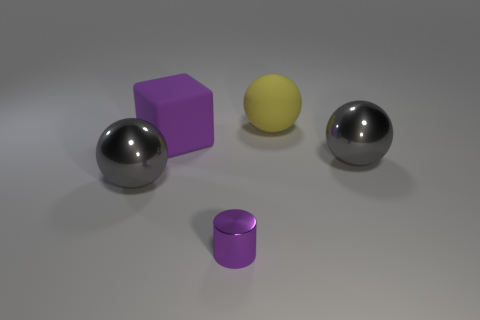Subtract all big metallic spheres. How many spheres are left? 1 Subtract all purple cylinders. How many gray spheres are left? 2 Subtract all gray balls. How many balls are left? 1 Add 3 big yellow spheres. How many objects exist? 8 Subtract 1 balls. How many balls are left? 2 Add 1 big gray metal things. How many big gray metal things are left? 3 Add 4 tiny brown cylinders. How many tiny brown cylinders exist? 4 Subtract 0 red spheres. How many objects are left? 5 Subtract all cubes. How many objects are left? 4 Subtract all red spheres. Subtract all purple blocks. How many spheres are left? 3 